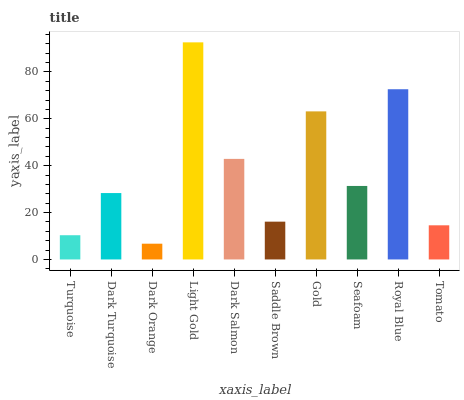Is Dark Turquoise the minimum?
Answer yes or no. No. Is Dark Turquoise the maximum?
Answer yes or no. No. Is Dark Turquoise greater than Turquoise?
Answer yes or no. Yes. Is Turquoise less than Dark Turquoise?
Answer yes or no. Yes. Is Turquoise greater than Dark Turquoise?
Answer yes or no. No. Is Dark Turquoise less than Turquoise?
Answer yes or no. No. Is Seafoam the high median?
Answer yes or no. Yes. Is Dark Turquoise the low median?
Answer yes or no. Yes. Is Turquoise the high median?
Answer yes or no. No. Is Saddle Brown the low median?
Answer yes or no. No. 